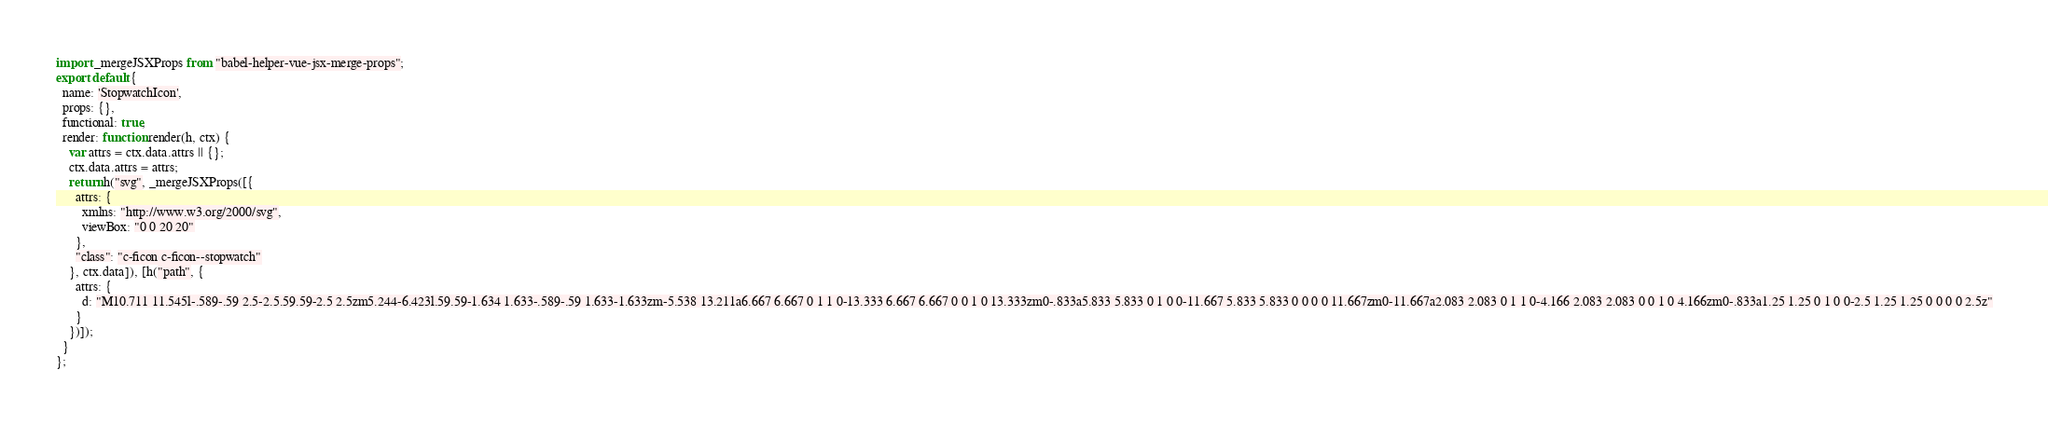Convert code to text. <code><loc_0><loc_0><loc_500><loc_500><_JavaScript_>import _mergeJSXProps from "babel-helper-vue-jsx-merge-props";
export default {
  name: 'StopwatchIcon',
  props: {},
  functional: true,
  render: function render(h, ctx) {
    var attrs = ctx.data.attrs || {};
    ctx.data.attrs = attrs;
    return h("svg", _mergeJSXProps([{
      attrs: {
        xmlns: "http://www.w3.org/2000/svg",
        viewBox: "0 0 20 20"
      },
      "class": "c-ficon c-ficon--stopwatch"
    }, ctx.data]), [h("path", {
      attrs: {
        d: "M10.711 11.545l-.589-.59 2.5-2.5.59.59-2.5 2.5zm5.244-6.423l.59.59-1.634 1.633-.589-.59 1.633-1.633zm-5.538 13.211a6.667 6.667 0 1 1 0-13.333 6.667 6.667 0 0 1 0 13.333zm0-.833a5.833 5.833 0 1 0 0-11.667 5.833 5.833 0 0 0 0 11.667zm0-11.667a2.083 2.083 0 1 1 0-4.166 2.083 2.083 0 0 1 0 4.166zm0-.833a1.25 1.25 0 1 0 0-2.5 1.25 1.25 0 0 0 0 2.5z"
      }
    })]);
  }
};</code> 